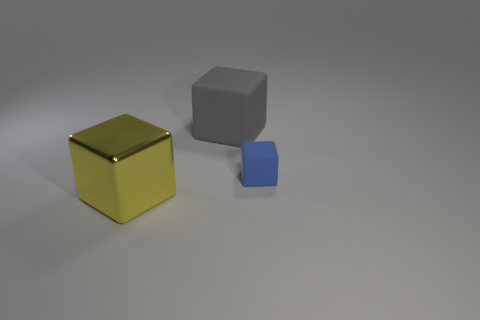How many objects are in front of the big gray rubber block and left of the tiny matte object?
Your answer should be compact. 1. Is the gray cube the same size as the yellow block?
Make the answer very short. Yes. Do the rubber cube that is to the left of the blue object and the yellow object have the same size?
Make the answer very short. Yes. What color is the matte cube left of the small rubber block?
Your answer should be very brief. Gray. What number of cyan cylinders are there?
Your answer should be compact. 0. Is the number of tiny blue matte things that are in front of the tiny blue rubber block the same as the number of large yellow metallic objects?
Make the answer very short. No. How many large yellow metal things are in front of the big rubber thing?
Your answer should be compact. 1. How big is the metallic thing?
Make the answer very short. Large. What color is the other block that is the same material as the blue block?
Give a very brief answer. Gray. How many metal objects are the same size as the gray matte thing?
Offer a terse response. 1. 